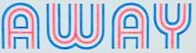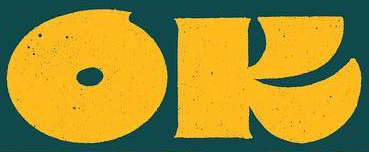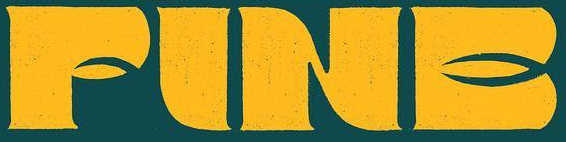What words can you see in these images in sequence, separated by a semicolon? AWAY; OK; FINE 